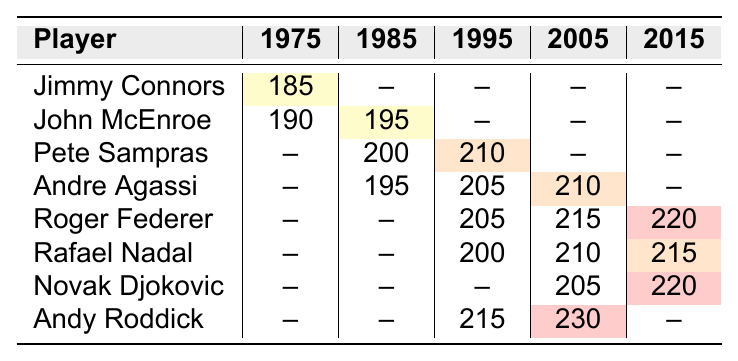What is the highest recorded serve speed in 2015? In the 2015 column, the highest recorded serve speed is from Roger Federer, which is 220 km/h.
Answer: 220 km/h Which player had a serve speed recorded in 1975? The only player with a recorded serve speed in 1975 is Jimmy Connors, at 185 km/h.
Answer: Jimmy Connors What is the average serve speed for Pete Sampras across the years he played? Pete Sampras has recorded speeds of 200 km/h in 1985 and 210 km/h in 1995. The average is (200 + 210) / 2 = 205 km/h.
Answer: 205 km/h Did Andy Roddick ever have a recorded serve speed greater than 220 km/h? The highest serve speed recorded for Andy Roddick is 230 km/h in 2005, which is indeed greater than 220 km/h.
Answer: Yes Who had the fastest serve speed in the 1995 era? In the 1995 column, Pete Sampras had the highest recorded serve speed of 210 km/h.
Answer: Pete Sampras What serve speed did Rafael Nadal record in 2015 compared to Roger Federer? Rafael Nadal recorded a serve speed of 215 km/h in 2015, which is 5 km/h slower than Roger Federer’s 220 km/h.
Answer: 215 km/h How much faster is John McEnroe's highest serve speed compared to Andre Agassi’s fastest serve speed? John McEnroe’s highest serve speed is 195 km/h in 1985 while Andre Agassi’s highest speed is 210 km/h in 2005. The difference is 210 - 195 = 15 km/h.
Answer: 15 km/h Which two players had recorded serve speeds in both the years 1995 and 2005? The players with recorded serve speeds in both 1995 and 2005 are Andre Agassi (205 km/h in 1995 and 210 km/h in 2005) and Roger Federer (205 km/h in 1995 and 215 km/h in 2005).
Answer: Andre Agassi and Roger Federer What can be inferred about the serving trends from 1975 to 2015 based on this table? The data shows a clear upward trend in serve speeds over the years, with increasing numbers in the later years, particularly evident in 2005 and 2015 with speeds reaching up to 230 km/h.
Answer: Serve speeds increased over the years 